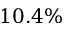<formula> <loc_0><loc_0><loc_500><loc_500>1 0 . 4 \%</formula> 